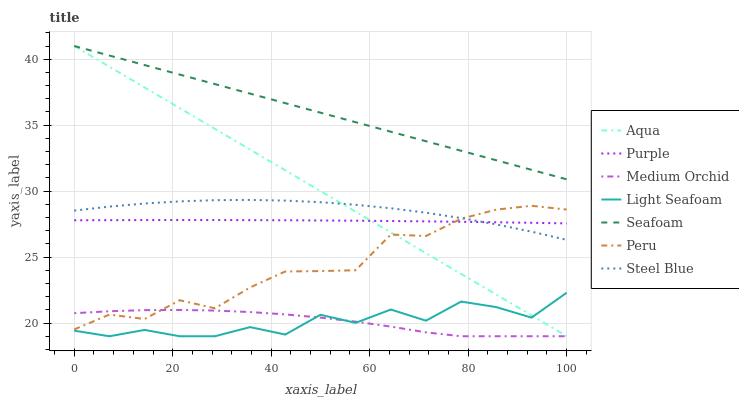Does Light Seafoam have the minimum area under the curve?
Answer yes or no. Yes. Does Seafoam have the maximum area under the curve?
Answer yes or no. Yes. Does Medium Orchid have the minimum area under the curve?
Answer yes or no. No. Does Medium Orchid have the maximum area under the curve?
Answer yes or no. No. Is Seafoam the smoothest?
Answer yes or no. Yes. Is Light Seafoam the roughest?
Answer yes or no. Yes. Is Medium Orchid the smoothest?
Answer yes or no. No. Is Medium Orchid the roughest?
Answer yes or no. No. Does Aqua have the lowest value?
Answer yes or no. No. Does Seafoam have the highest value?
Answer yes or no. Yes. Does Medium Orchid have the highest value?
Answer yes or no. No. Is Medium Orchid less than Purple?
Answer yes or no. Yes. Is Seafoam greater than Medium Orchid?
Answer yes or no. Yes. Does Light Seafoam intersect Medium Orchid?
Answer yes or no. Yes. Is Light Seafoam less than Medium Orchid?
Answer yes or no. No. Is Light Seafoam greater than Medium Orchid?
Answer yes or no. No. Does Medium Orchid intersect Purple?
Answer yes or no. No. 